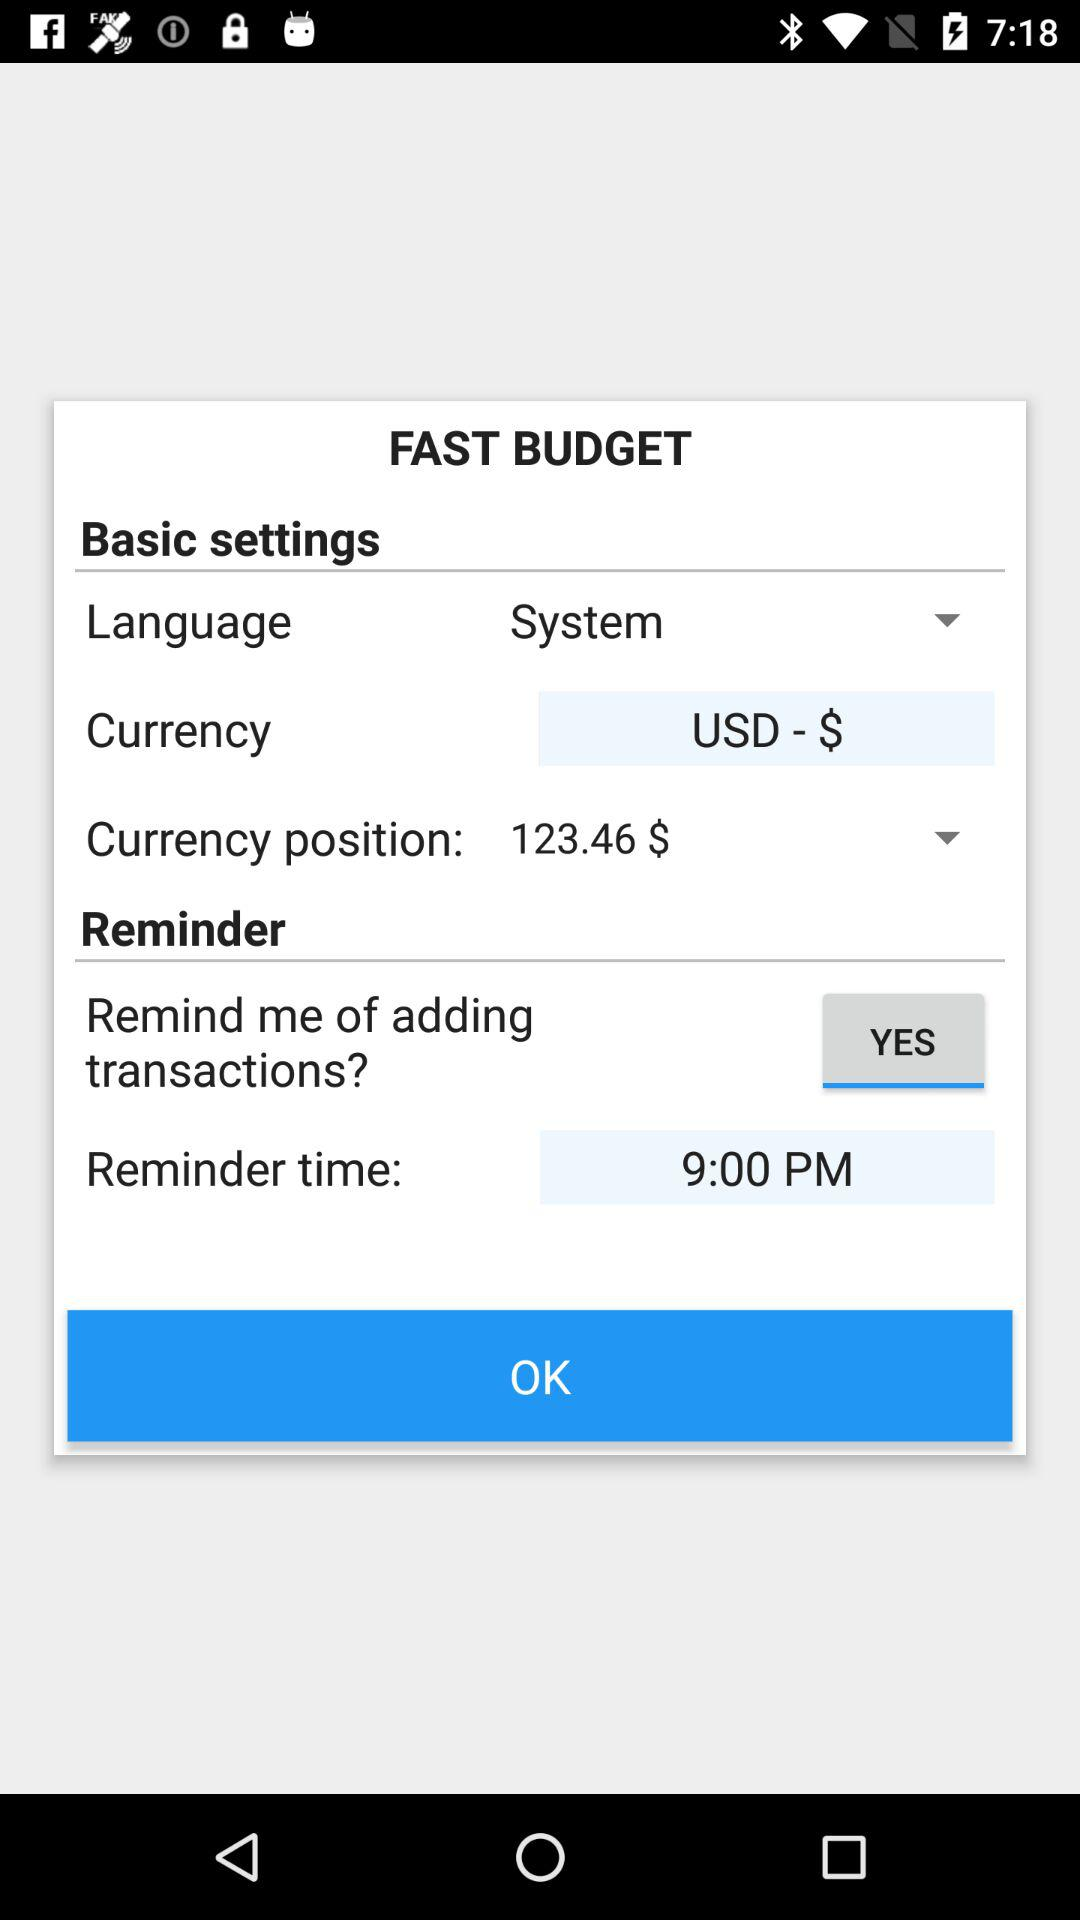Which language is selected under the basic settings? The selected language under the basic settings is "System". 